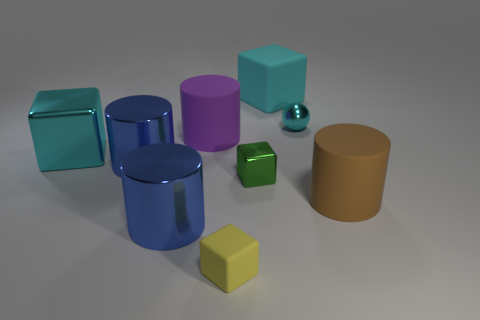What number of balls are to the left of the large cylinder right of the shiny ball? There are no balls to the left of the large cylinder that is to the right of the shiny ball. However, there is one green cube positioned to the left of the mentioned cylinder. 